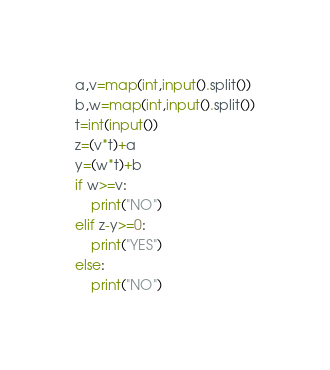<code> <loc_0><loc_0><loc_500><loc_500><_Python_>a,v=map(int,input().split())
b,w=map(int,input().split())
t=int(input())
z=(v*t)+a
y=(w*t)+b
if w>=v:
    print("NO")
elif z-y>=0:
    print("YES")
else:
    print("NO")
</code> 